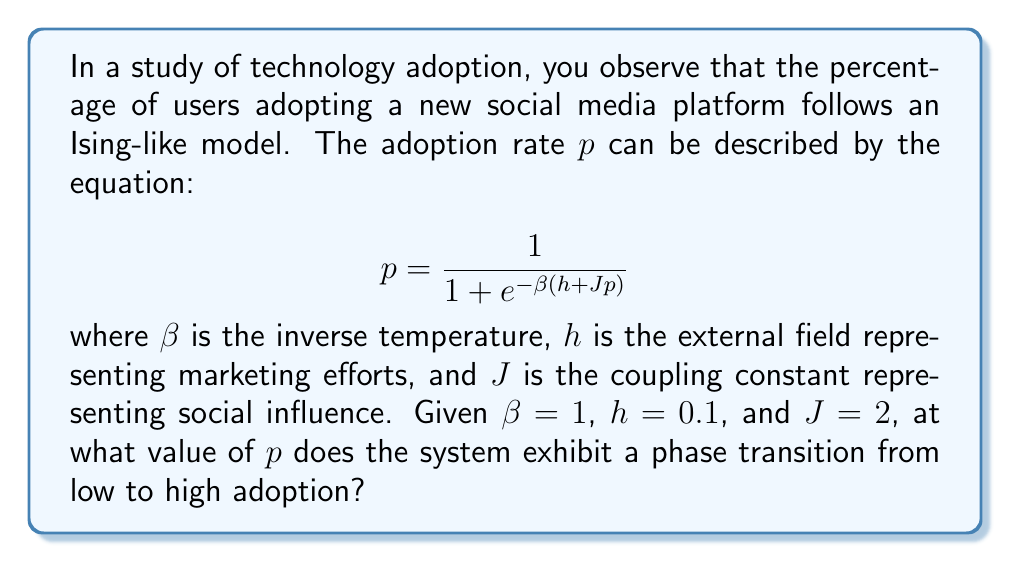What is the answer to this math problem? To find the phase transition point, we need to analyze the stability of the system:

1. The adoption rate equation can be rewritten as:
   $$ p = f(p) = \frac{1}{1 + e^{-\beta(h + Jp)}} $$

2. A phase transition occurs when the slope of $f(p)$ at the fixed point equals 1:
   $$ \left.\frac{df}{dp}\right|_{p=p_c} = 1 $$

3. Calculate the derivative of $f(p)$:
   $$ \frac{df}{dp} = \frac{\beta J e^{-\beta(h + Jp)}}{(1 + e^{-\beta(h + Jp)})^2} $$

4. Set the derivative equal to 1 and substitute the given values:
   $$ \frac{1 \cdot 2 \cdot e^{-(0.1 + 2p)}}{(1 + e^{-(0.1 + 2p)})^2} = 1 $$

5. Simplify:
   $$ 2e^{-(0.1 + 2p)} = (1 + e^{-(0.1 + 2p)})^2 $$

6. Let $x = e^{-(0.1 + 2p)}$, then:
   $$ 2x = (1 + x)^2 $$
   $$ 2x = 1 + 2x + x^2 $$
   $$ x^2 - 1 = 0 $$
   $$ x = 1 $$

7. Solve for $p$:
   $$ e^{-(0.1 + 2p)} = 1 $$
   $$ -(0.1 + 2p) = 0 $$
   $$ p = -0.05 $$

8. The critical adoption rate $p_c$ is the positive solution:
   $$ p_c = 0.05 $$

This represents the phase transition point where the system shifts from low to high adoption.
Answer: $p_c = 0.05$ 